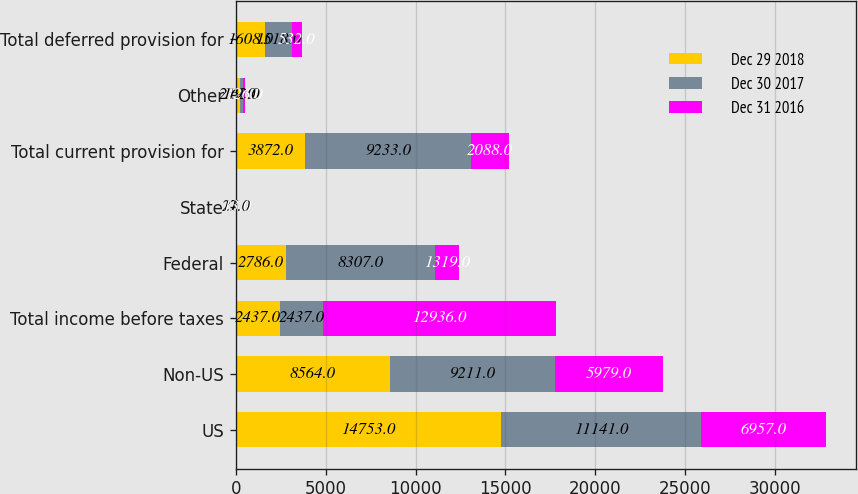<chart> <loc_0><loc_0><loc_500><loc_500><stacked_bar_chart><ecel><fcel>US<fcel>Non-US<fcel>Total income before taxes<fcel>Federal<fcel>State<fcel>Total current provision for<fcel>Other<fcel>Total deferred provision for<nl><fcel>Dec 29 2018<fcel>14753<fcel>8564<fcel>2437<fcel>2786<fcel>11<fcel>3872<fcel>219<fcel>1608<nl><fcel>Dec 30 2017<fcel>11141<fcel>9211<fcel>2437<fcel>8307<fcel>27<fcel>9233<fcel>162<fcel>1518<nl><fcel>Dec 31 2016<fcel>6957<fcel>5979<fcel>12936<fcel>1319<fcel>13<fcel>2088<fcel>126<fcel>532<nl></chart> 